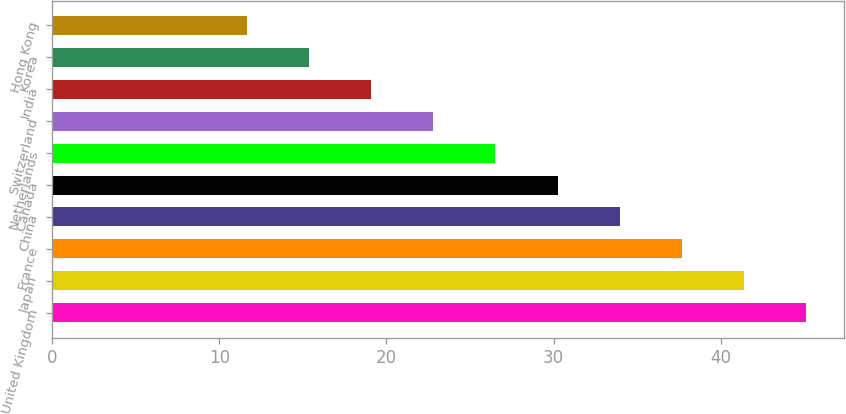<chart> <loc_0><loc_0><loc_500><loc_500><bar_chart><fcel>United Kingdom<fcel>Japan<fcel>France<fcel>China<fcel>Canada<fcel>Netherlands<fcel>Switzerland<fcel>India<fcel>Korea<fcel>Hong Kong<nl><fcel>45.12<fcel>41.4<fcel>37.68<fcel>33.96<fcel>30.24<fcel>26.52<fcel>22.8<fcel>19.08<fcel>15.36<fcel>11.64<nl></chart> 